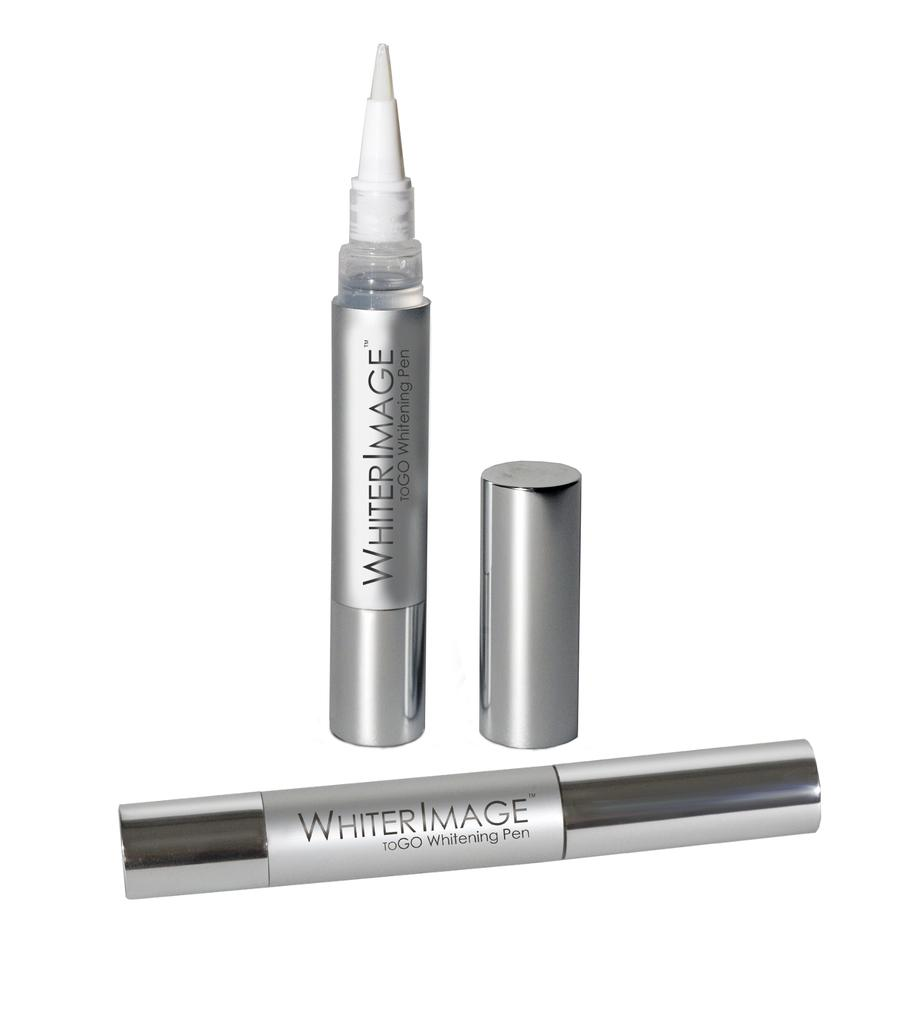<image>
Render a clear and concise summary of the photo. Whiter Image to go whitening pen in a picture 